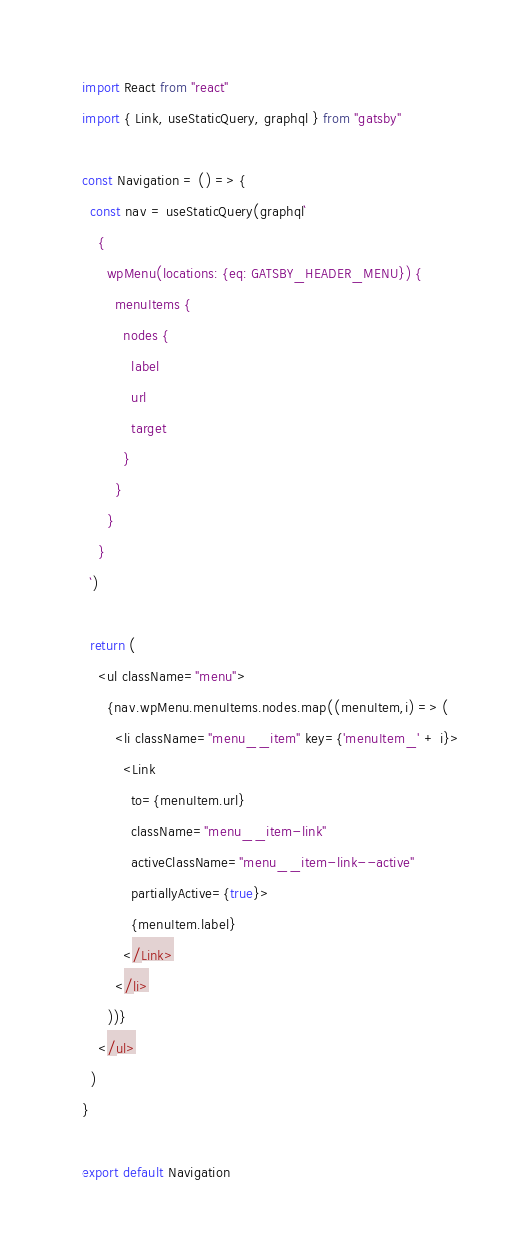<code> <loc_0><loc_0><loc_500><loc_500><_JavaScript_>import React from "react"
import { Link, useStaticQuery, graphql } from "gatsby"

const Navigation = () => {
  const nav = useStaticQuery(graphql`
    {
      wpMenu(locations: {eq: GATSBY_HEADER_MENU}) {
        menuItems {
          nodes {
            label
            url
            target
          }
        }
      }
    }
  `)

  return (
    <ul className="menu">
      {nav.wpMenu.menuItems.nodes.map((menuItem,i) => (
        <li className="menu__item" key={'menuItem_' + i}>
          <Link 
            to={menuItem.url} 
            className="menu__item-link" 
            activeClassName="menu__item-link--active"
            partiallyActive={true}>
            {menuItem.label}
          </Link>
        </li>
      ))}
    </ul>
  )
}

export default Navigation
</code> 